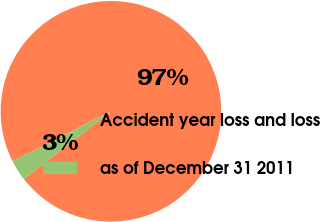Convert chart to OTSL. <chart><loc_0><loc_0><loc_500><loc_500><pie_chart><fcel>Accident year loss and loss<fcel>as of December 31 2011<nl><fcel>96.98%<fcel>3.02%<nl></chart> 